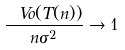Convert formula to latex. <formula><loc_0><loc_0><loc_500><loc_500>\frac { \ V o ( T ( n ) ) } { n \sigma ^ { 2 } } \to 1</formula> 